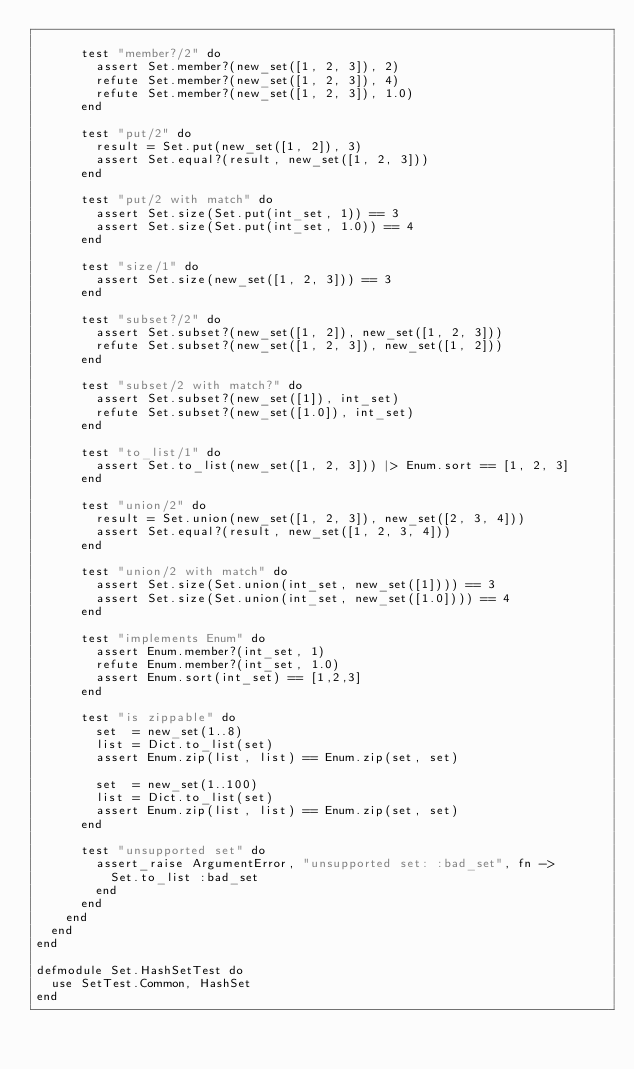Convert code to text. <code><loc_0><loc_0><loc_500><loc_500><_Elixir_>
      test "member?/2" do
        assert Set.member?(new_set([1, 2, 3]), 2)
        refute Set.member?(new_set([1, 2, 3]), 4)
        refute Set.member?(new_set([1, 2, 3]), 1.0)
      end

      test "put/2" do
        result = Set.put(new_set([1, 2]), 3)
        assert Set.equal?(result, new_set([1, 2, 3]))
      end

      test "put/2 with match" do
        assert Set.size(Set.put(int_set, 1)) == 3
        assert Set.size(Set.put(int_set, 1.0)) == 4
      end

      test "size/1" do
        assert Set.size(new_set([1, 2, 3])) == 3
      end

      test "subset?/2" do
        assert Set.subset?(new_set([1, 2]), new_set([1, 2, 3]))
        refute Set.subset?(new_set([1, 2, 3]), new_set([1, 2]))
      end

      test "subset/2 with match?" do
        assert Set.subset?(new_set([1]), int_set)
        refute Set.subset?(new_set([1.0]), int_set)
      end

      test "to_list/1" do
        assert Set.to_list(new_set([1, 2, 3])) |> Enum.sort == [1, 2, 3]
      end

      test "union/2" do
        result = Set.union(new_set([1, 2, 3]), new_set([2, 3, 4]))
        assert Set.equal?(result, new_set([1, 2, 3, 4]))
      end

      test "union/2 with match" do
        assert Set.size(Set.union(int_set, new_set([1]))) == 3
        assert Set.size(Set.union(int_set, new_set([1.0]))) == 4
      end

      test "implements Enum" do
        assert Enum.member?(int_set, 1)
        refute Enum.member?(int_set, 1.0)
        assert Enum.sort(int_set) == [1,2,3]
      end

      test "is zippable" do
        set  = new_set(1..8)
        list = Dict.to_list(set)
        assert Enum.zip(list, list) == Enum.zip(set, set)

        set  = new_set(1..100)
        list = Dict.to_list(set)
        assert Enum.zip(list, list) == Enum.zip(set, set)
      end

      test "unsupported set" do
        assert_raise ArgumentError, "unsupported set: :bad_set", fn ->
          Set.to_list :bad_set
        end
      end
    end
  end
end

defmodule Set.HashSetTest do
  use SetTest.Common, HashSet
end
</code> 